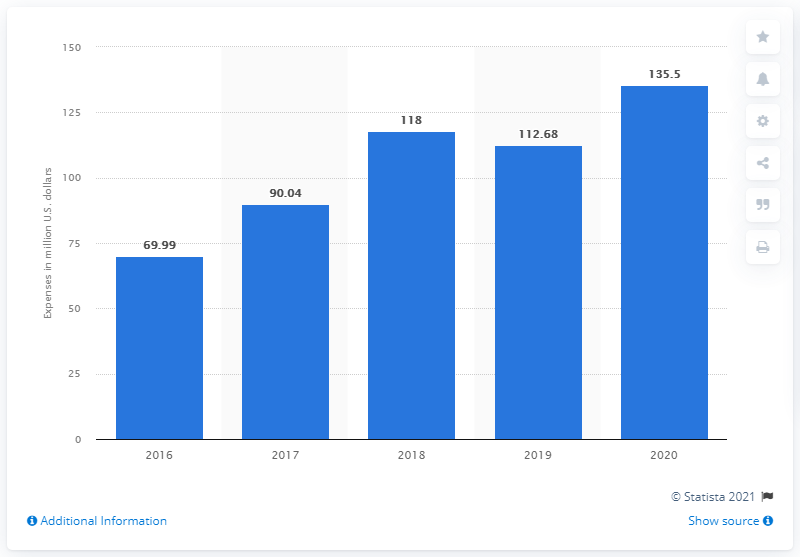Indicate a few pertinent items in this graphic. Razer's sales and marketing spending in 2020 was approximately 135.5%. 